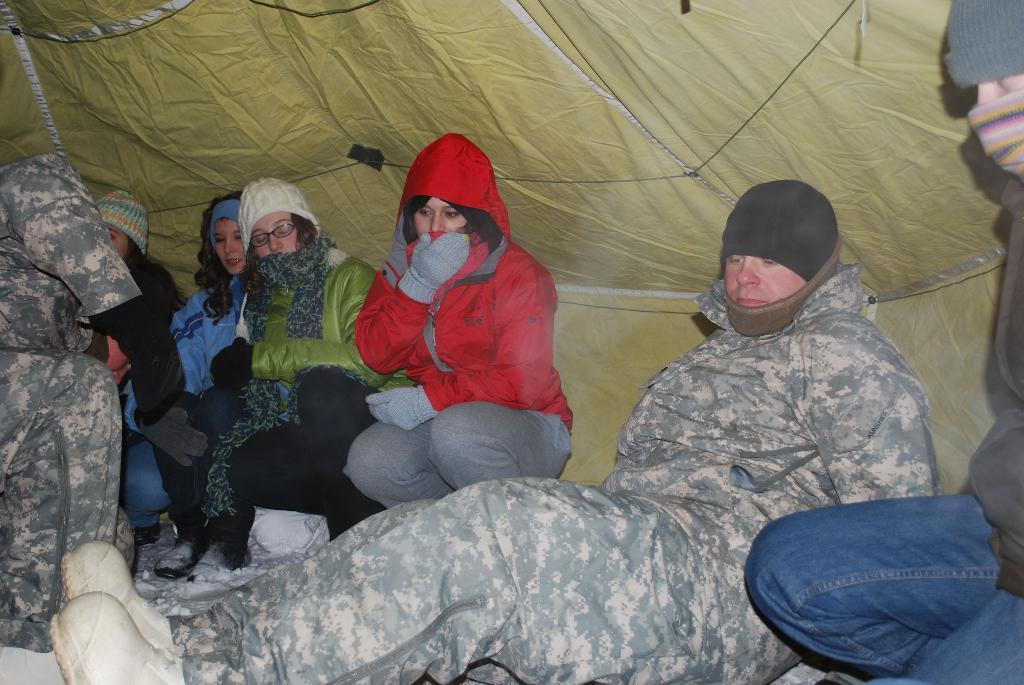What is the main subject of the image? The main subject of the image is a group of people. What are the people wearing in the image? The people are wearing gloves in the image. Where are the people sitting in the image? The people are sitting under a tent in the image. What is the position of some people in the image? Some people are sitting on their knees in the image. What type of toothpaste is being used by the people in the image? There is no toothpaste present in the image; the people are wearing gloves and sitting under a tent. Can you tell me which vein is visible on the people's hands in the image? There is no need to examine the veins of the people's hands in the image, as the focus is on their gloves and sitting positions. 